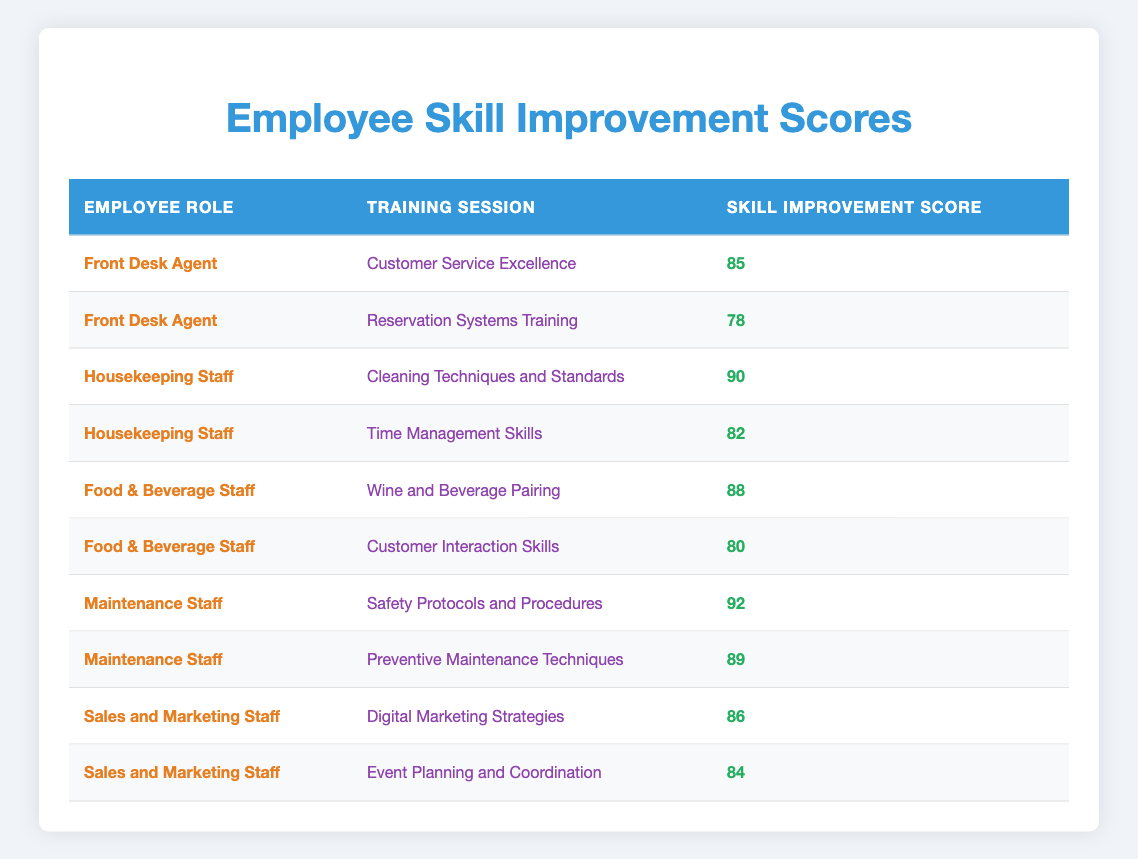What is the highest Skill Improvement Score among Front Desk Agents? The two scores for Front Desk Agents are 85 and 78. The highest score is 85.
Answer: 85 What is the Skill Improvement Score for Housekeeping Staff in Cleaning Techniques and Standards? The score for Housekeeping Staff in Cleaning Techniques and Standards is explicitly listed as 90 in the table.
Answer: 90 Which training session had the highest score overall? The highest score in the entire table is 92 for the Maintenance Staff in Safety Protocols and Procedures. Therefore, this training session had the highest score overall.
Answer: Safety Protocols and Procedures What is the average Skill Improvement Score for Food & Beverage Staff across both training sessions? The scores for Food & Beverage Staff are 88 and 80. The sum of these scores is (88 + 80) = 168, and there are 2 training sessions. Therefore, the average is 168/2 = 84.
Answer: 84 Did Sales and Marketing Staff achieve a Skill Improvement Score higher than 85 in any training session? The scores for Sales and Marketing Staff are 86 and 84. One of these scores (86) is higher than 85, confirming that yes, they achieved a score above 85 in Digital Marketing Strategies.
Answer: Yes Which employee role had the lowest total Skill Improvement Score from their training sessions? We calculate the total scores for each role: Front Desk Agents = 85 + 78 = 163, Housekeeping Staff = 90 + 82 = 172, Food & Beverage Staff = 88 + 80 = 168, Maintenance Staff = 92 + 89 = 181, Sales and Marketing Staff = 86 + 84 = 170. The lowest total is 163, for Front Desk Agents.
Answer: Front Desk Agents How many training sessions had a Skill Improvement Score below 80? The only scores below 80 are for Front Desk Agents with 78 and Food & Beverage Staff with 80 (not below), summing to only one training session.
Answer: 1 What is the total Skill Improvement Score for all Maintenance Staff training sessions? The scores for Maintenance Staff are 92 and 89. Adding these scores gives a total of (92 + 89) = 181.
Answer: 181 